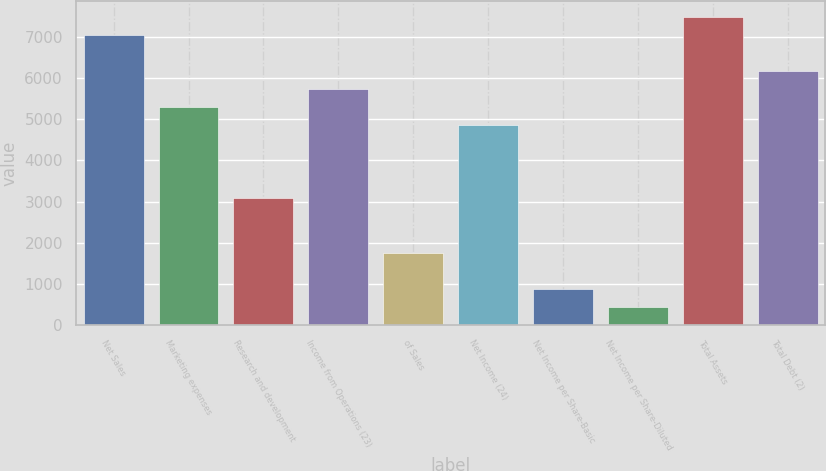Convert chart to OTSL. <chart><loc_0><loc_0><loc_500><loc_500><bar_chart><fcel>Net Sales<fcel>Marketing expenses<fcel>Research and development<fcel>Income from Operations (23)<fcel>of Sales<fcel>Net Income (24)<fcel>Net Income per Share-Basic<fcel>Net Income per Share-Diluted<fcel>Total Assets<fcel>Total Debt (2)<nl><fcel>7049.15<fcel>5287.03<fcel>3084.38<fcel>5727.56<fcel>1762.79<fcel>4846.5<fcel>881.73<fcel>441.2<fcel>7489.68<fcel>6168.09<nl></chart> 